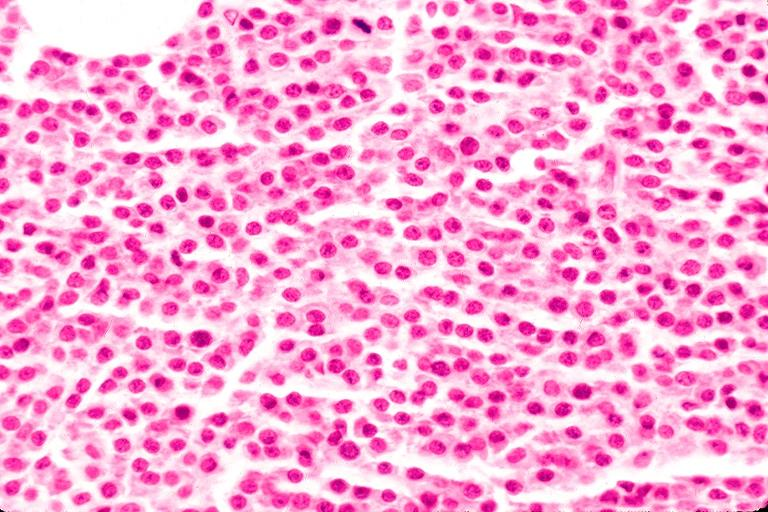s multiple myeloma present?
Answer the question using a single word or phrase. No 